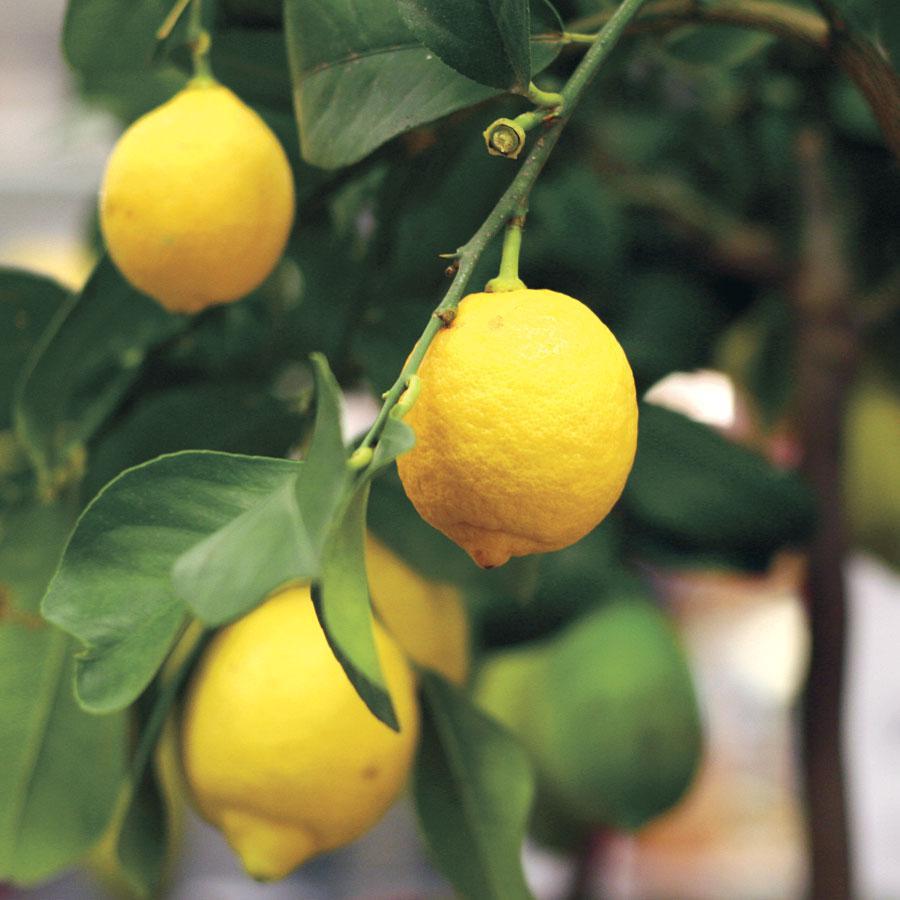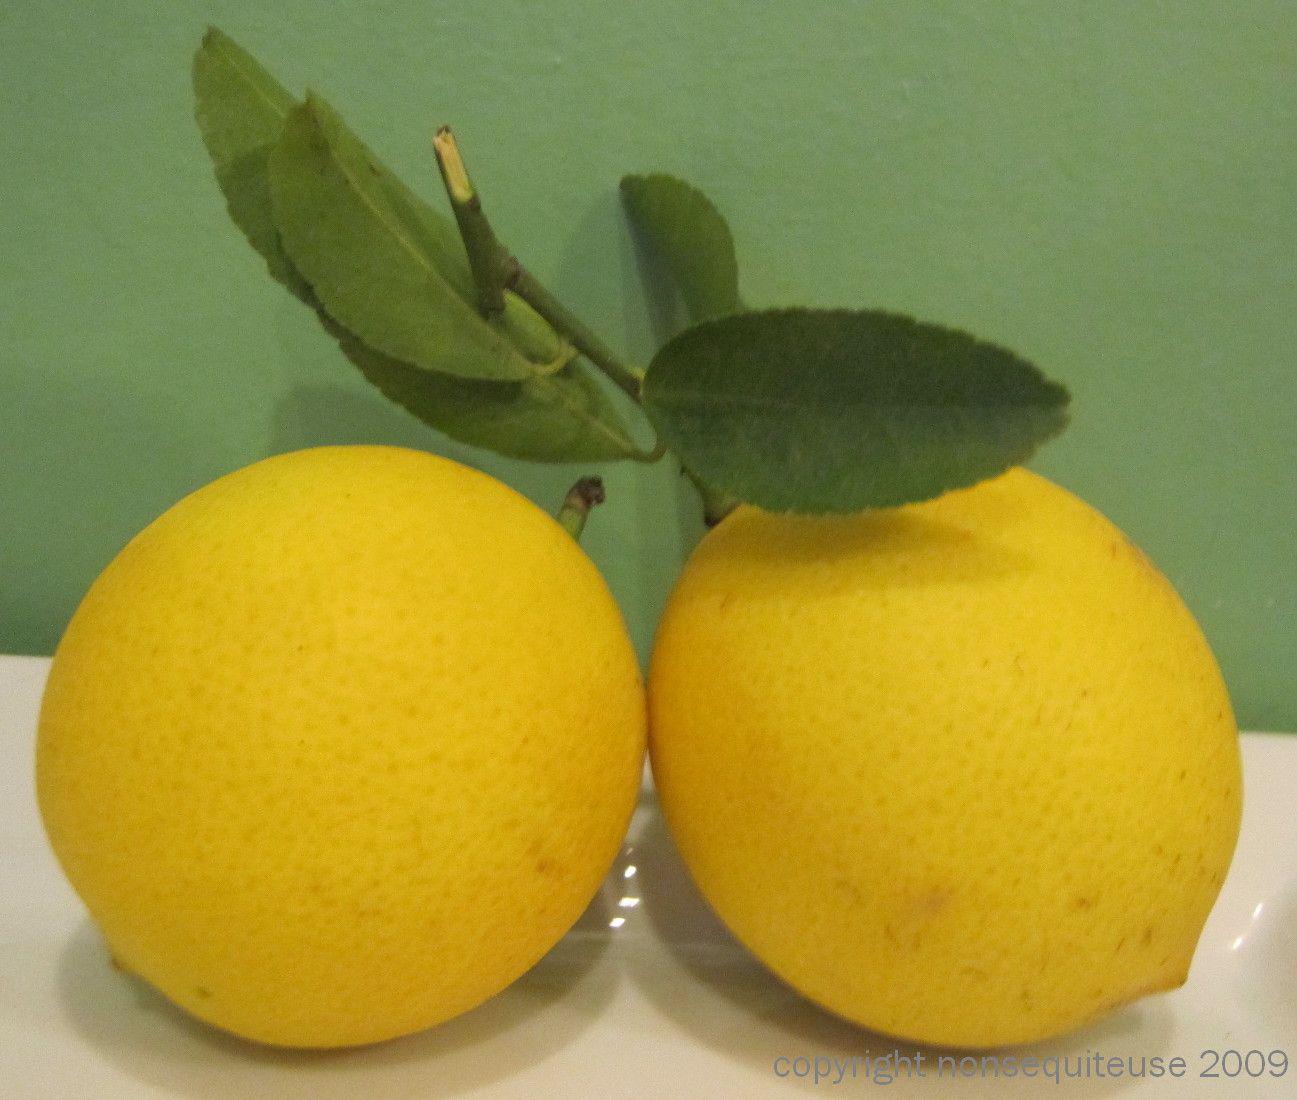The first image is the image on the left, the second image is the image on the right. Evaluate the accuracy of this statement regarding the images: "One image shows multiple lemons still on their tree, while the other image shows multiple lemons that have been picked from the tree but still have a few leaves with them.". Is it true? Answer yes or no. Yes. 